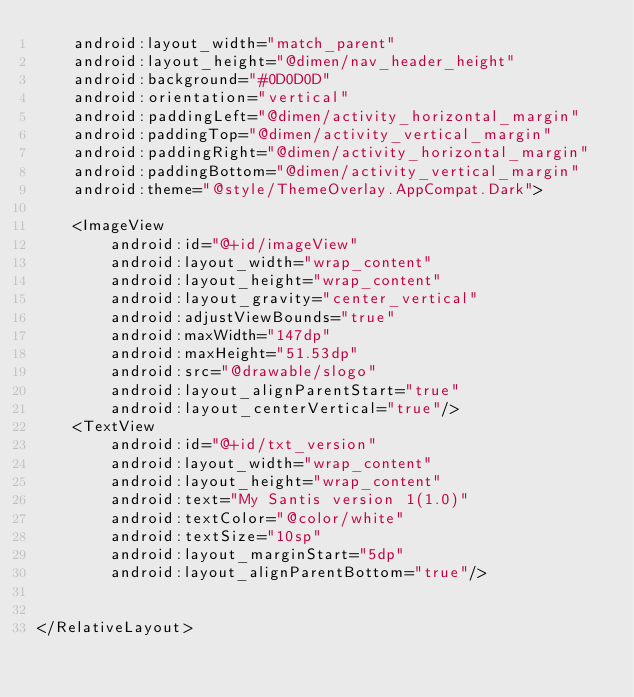Convert code to text. <code><loc_0><loc_0><loc_500><loc_500><_XML_>    android:layout_width="match_parent"
    android:layout_height="@dimen/nav_header_height"
    android:background="#0D0D0D"
    android:orientation="vertical"
    android:paddingLeft="@dimen/activity_horizontal_margin"
    android:paddingTop="@dimen/activity_vertical_margin"
    android:paddingRight="@dimen/activity_horizontal_margin"
    android:paddingBottom="@dimen/activity_vertical_margin"
    android:theme="@style/ThemeOverlay.AppCompat.Dark">

    <ImageView
        android:id="@+id/imageView"
        android:layout_width="wrap_content"
        android:layout_height="wrap_content"
        android:layout_gravity="center_vertical"
        android:adjustViewBounds="true"
        android:maxWidth="147dp"
        android:maxHeight="51.53dp"
        android:src="@drawable/slogo"
        android:layout_alignParentStart="true"
        android:layout_centerVertical="true"/>
    <TextView
        android:id="@+id/txt_version"
        android:layout_width="wrap_content"
        android:layout_height="wrap_content"
        android:text="My Santis version 1(1.0)"
        android:textColor="@color/white"
        android:textSize="10sp"
        android:layout_marginStart="5dp"
        android:layout_alignParentBottom="true"/>


</RelativeLayout>
</code> 